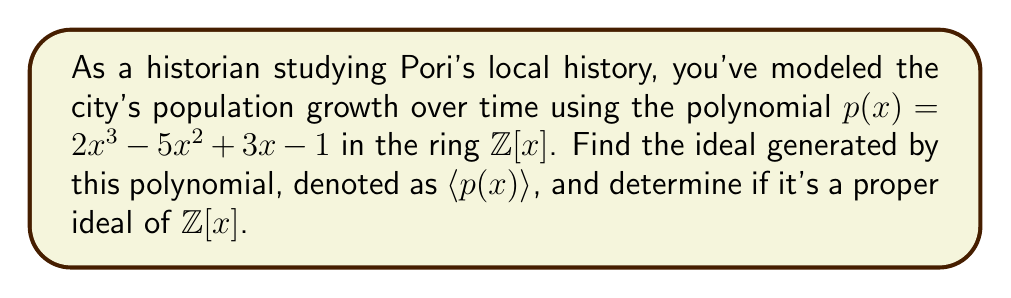Teach me how to tackle this problem. Let's approach this step-by-step:

1) The ideal generated by $p(x) = 2x^3 - 5x^2 + 3x - 1$ in $\mathbb{Z}[x]$ is defined as:

   $\langle p(x) \rangle = \{f(x)p(x) : f(x) \in \mathbb{Z}[x]\}$

2) This means that any element in the ideal can be expressed as the product of $p(x)$ and some polynomial in $\mathbb{Z}[x]$.

3) To determine if this is a proper ideal, we need to check if $\langle p(x) \rangle = \mathbb{Z}[x]$.

4) If we can find a constant in $\langle p(x) \rangle$, then the ideal would be the entire ring $\mathbb{Z}[x]$.

5) The constant term of $p(x)$ is -1. This means that $-p(x) \in \langle p(x) \rangle$ has a constant term of 1.

6) Since both $p(x)$ and $-p(x)$ are in the ideal, their greatest common divisor (GCD) is also in the ideal.

7) $GCD(p(x), -p(x)) = 1$ because the coefficients of $p(x)$ are relatively prime (their GCD is 1).

8) Therefore, 1 is in the ideal $\langle p(x) \rangle$.

9) If 1 is in the ideal, then every element of $\mathbb{Z}[x]$ is in the ideal, because for any $q(x) \in \mathbb{Z}[x]$, we have $q(x) = q(x) \cdot 1 \in \langle p(x) \rangle$.

Thus, $\langle p(x) \rangle = \mathbb{Z}[x]$, which means it's not a proper ideal.
Answer: $\langle p(x) \rangle = \mathbb{Z}[x]$; not a proper ideal 